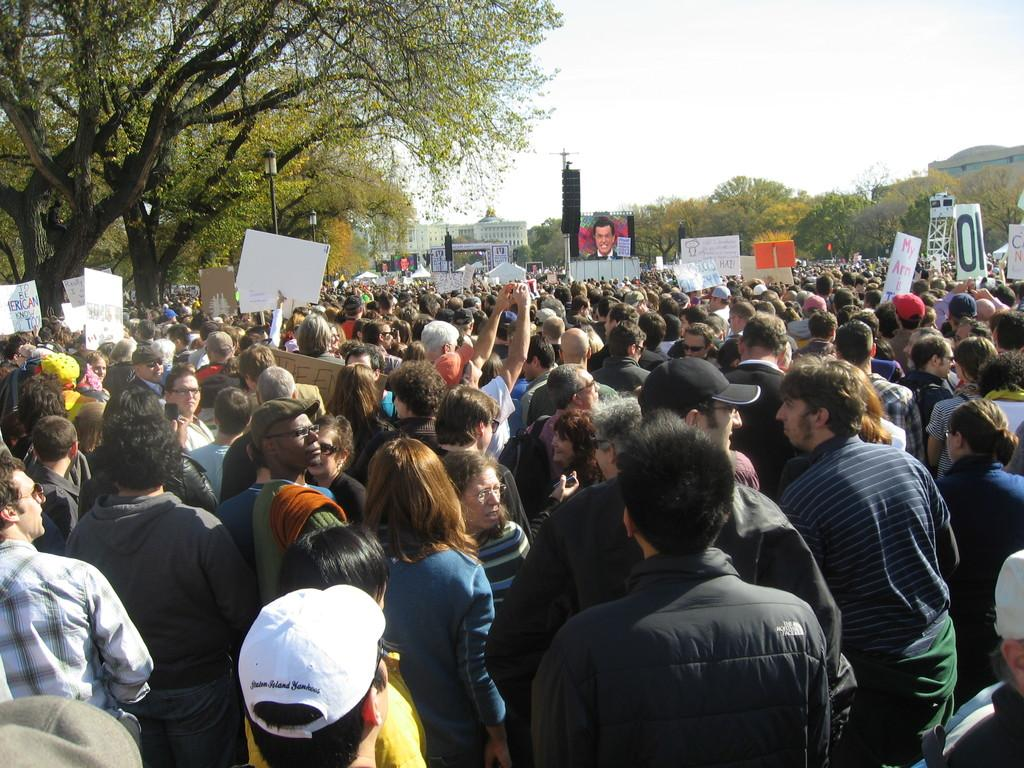What is the main subject in the foreground of the image? There is a crowd in the foreground of the image. Where is the crowd located? The crowd is on the road. What else can be seen in the foreground of the image? There are boards in the foreground of the image. What can be seen in the background of the image? There are trees, light poles, buildings, a screen, and the sky visible in the background of the image. Can you describe the time of day when the image was likely taken? The image was likely taken during the day, as the sky is visible and there is no indication of darkness. How does the crowd show respect to the nail in the image? There is no nail present in the image, and therefore no such interaction can be observed. 